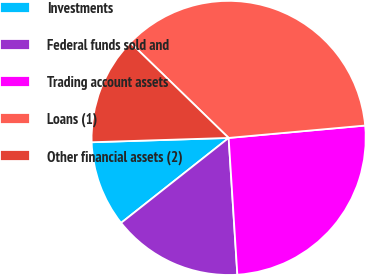<chart> <loc_0><loc_0><loc_500><loc_500><pie_chart><fcel>Investments<fcel>Federal funds sold and<fcel>Trading account assets<fcel>Loans (1)<fcel>Other financial assets (2)<nl><fcel>10.14%<fcel>15.37%<fcel>25.43%<fcel>36.3%<fcel>12.76%<nl></chart> 